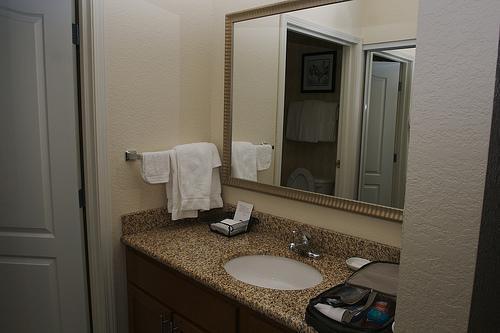How many sinks are there?
Give a very brief answer. 1. 